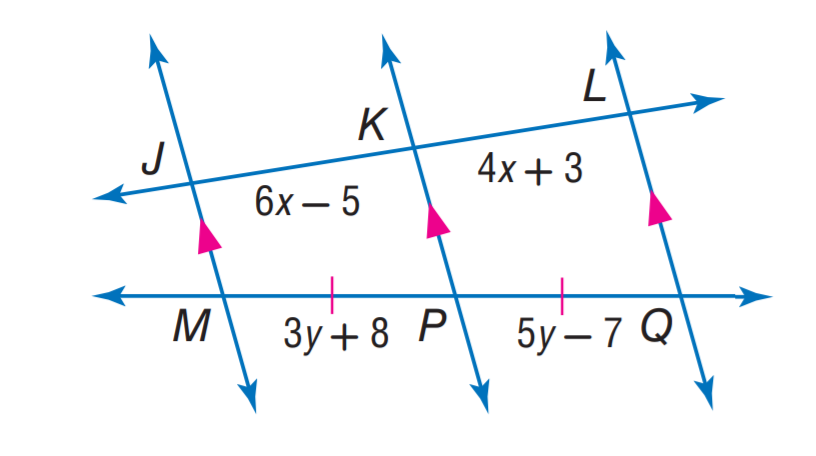Question: Find y.
Choices:
A. 6.5
B. 7
C. 7.5
D. 9
Answer with the letter. Answer: C Question: Find x.
Choices:
A. 3
B. 4
C. 6
D. 7
Answer with the letter. Answer: B 